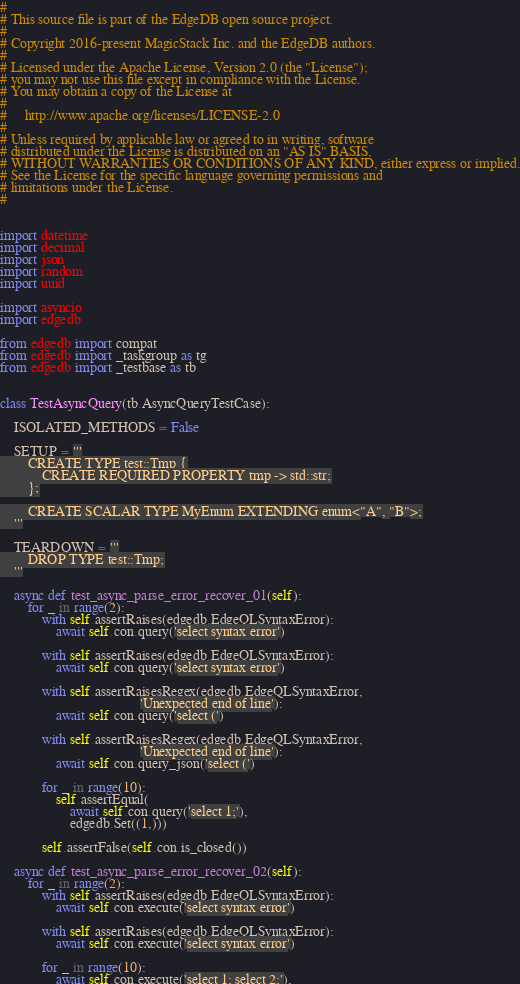<code> <loc_0><loc_0><loc_500><loc_500><_Python_>#
# This source file is part of the EdgeDB open source project.
#
# Copyright 2016-present MagicStack Inc. and the EdgeDB authors.
#
# Licensed under the Apache License, Version 2.0 (the "License");
# you may not use this file except in compliance with the License.
# You may obtain a copy of the License at
#
#     http://www.apache.org/licenses/LICENSE-2.0
#
# Unless required by applicable law or agreed to in writing, software
# distributed under the License is distributed on an "AS IS" BASIS,
# WITHOUT WARRANTIES OR CONDITIONS OF ANY KIND, either express or implied.
# See the License for the specific language governing permissions and
# limitations under the License.
#


import datetime
import decimal
import json
import random
import uuid

import asyncio
import edgedb

from edgedb import compat
from edgedb import _taskgroup as tg
from edgedb import _testbase as tb


class TestAsyncQuery(tb.AsyncQueryTestCase):

    ISOLATED_METHODS = False

    SETUP = '''
        CREATE TYPE test::Tmp {
            CREATE REQUIRED PROPERTY tmp -> std::str;
        };

        CREATE SCALAR TYPE MyEnum EXTENDING enum<"A", "B">;
    '''

    TEARDOWN = '''
        DROP TYPE test::Tmp;
    '''

    async def test_async_parse_error_recover_01(self):
        for _ in range(2):
            with self.assertRaises(edgedb.EdgeQLSyntaxError):
                await self.con.query('select syntax error')

            with self.assertRaises(edgedb.EdgeQLSyntaxError):
                await self.con.query('select syntax error')

            with self.assertRaisesRegex(edgedb.EdgeQLSyntaxError,
                                        'Unexpected end of line'):
                await self.con.query('select (')

            with self.assertRaisesRegex(edgedb.EdgeQLSyntaxError,
                                        'Unexpected end of line'):
                await self.con.query_json('select (')

            for _ in range(10):
                self.assertEqual(
                    await self.con.query('select 1;'),
                    edgedb.Set((1,)))

            self.assertFalse(self.con.is_closed())

    async def test_async_parse_error_recover_02(self):
        for _ in range(2):
            with self.assertRaises(edgedb.EdgeQLSyntaxError):
                await self.con.execute('select syntax error')

            with self.assertRaises(edgedb.EdgeQLSyntaxError):
                await self.con.execute('select syntax error')

            for _ in range(10):
                await self.con.execute('select 1; select 2;'),
</code> 